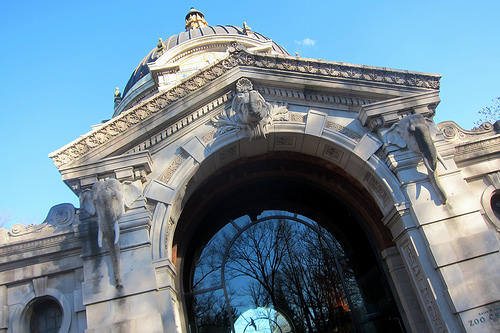<image>
Is there a elephant to the right of the column? No. The elephant is not to the right of the column. The horizontal positioning shows a different relationship. 